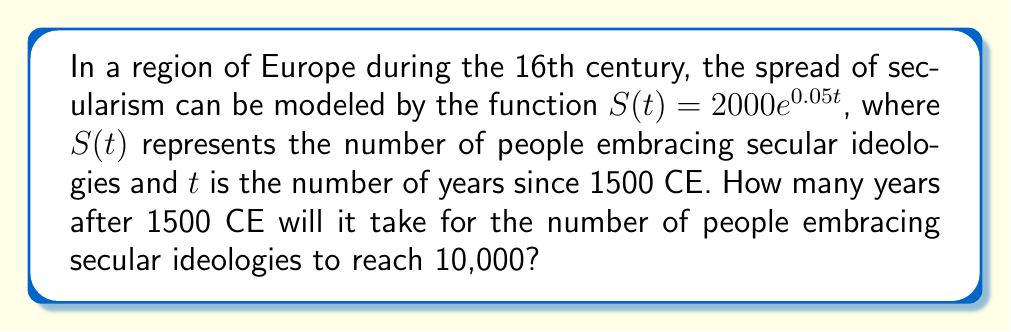Teach me how to tackle this problem. Let's approach this step-by-step:

1) We're given the function $S(t) = 2000e^{0.05t}$, where $S(t)$ is the number of people and $t$ is the number of years since 1500 CE.

2) We want to find $t$ when $S(t) = 10000$. So, we can set up the equation:

   $10000 = 2000e^{0.05t}$

3) Divide both sides by 2000:

   $5 = e^{0.05t}$

4) Take the natural logarithm of both sides:

   $\ln(5) = \ln(e^{0.05t})$

5) Using the properties of logarithms, we can simplify the right side:

   $\ln(5) = 0.05t$

6) Now, solve for $t$:

   $t = \frac{\ln(5)}{0.05}$

7) Calculate this value:

   $t = \frac{\ln(5)}{0.05} \approx 32.19$ years

8) Since we're dealing with historical events, we should round to the nearest whole year.

Therefore, it will take approximately 32 years after 1500 CE for the number of people embracing secular ideologies to reach 10,000.
Answer: 32 years 